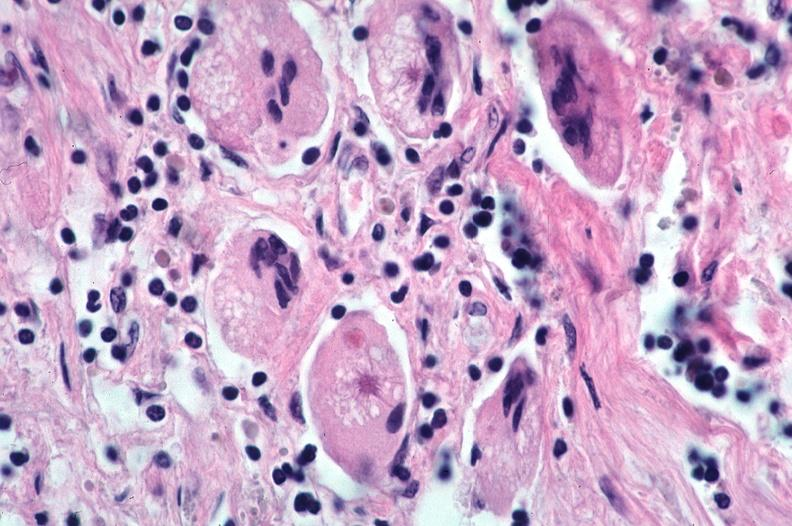where is this?
Answer the question using a single word or phrase. Lung 